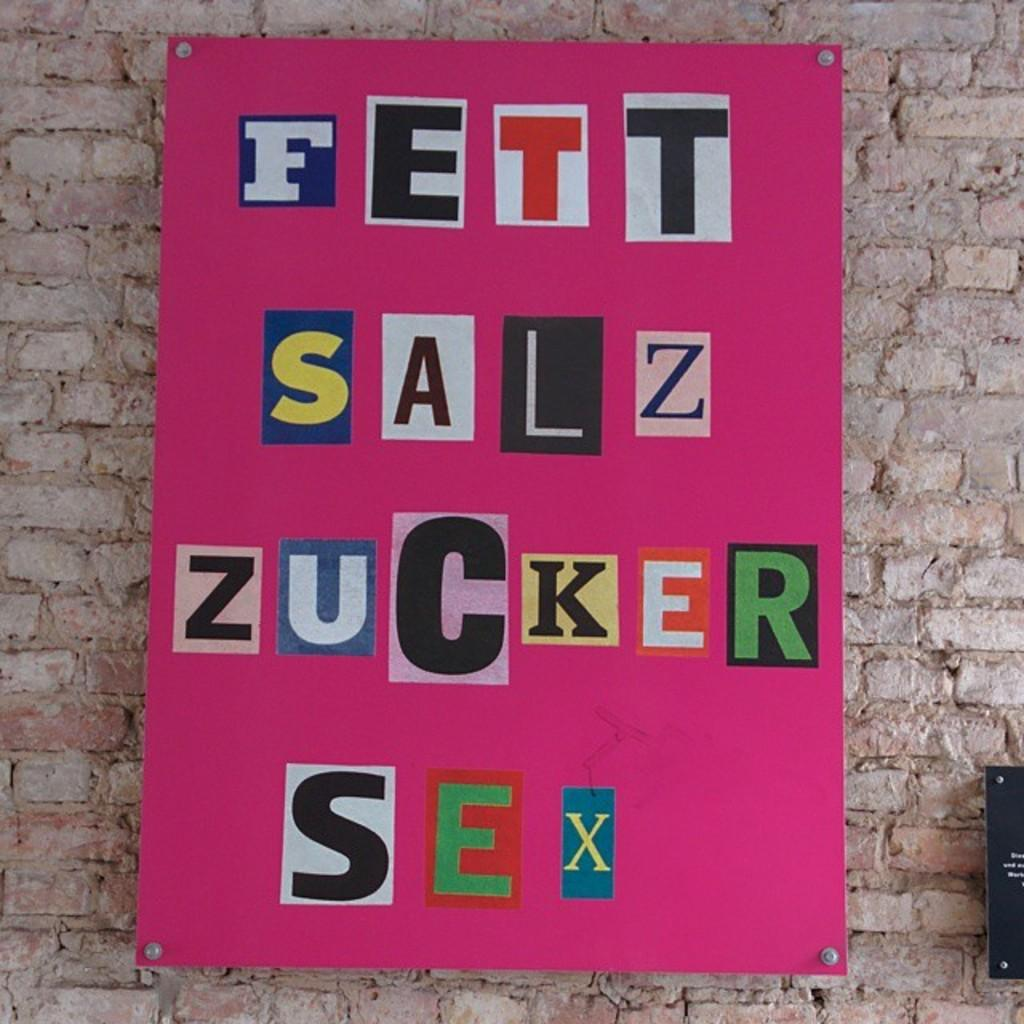<image>
Write a terse but informative summary of the picture. a pink poter board with cut out letters spelling fett sale zucker sex 